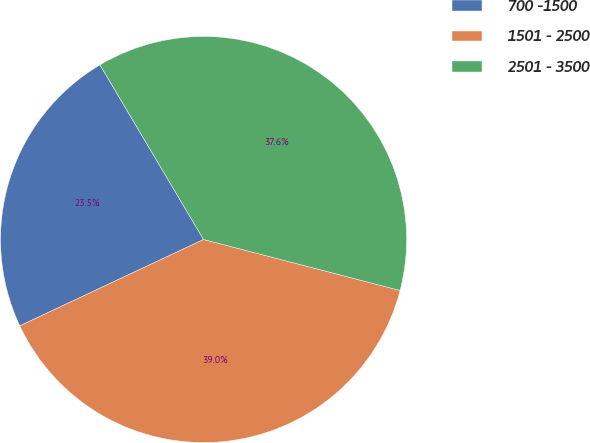Convert chart. <chart><loc_0><loc_0><loc_500><loc_500><pie_chart><fcel>700 -1500<fcel>1501 - 2500<fcel>2501 - 3500<nl><fcel>23.47%<fcel>38.97%<fcel>37.56%<nl></chart> 